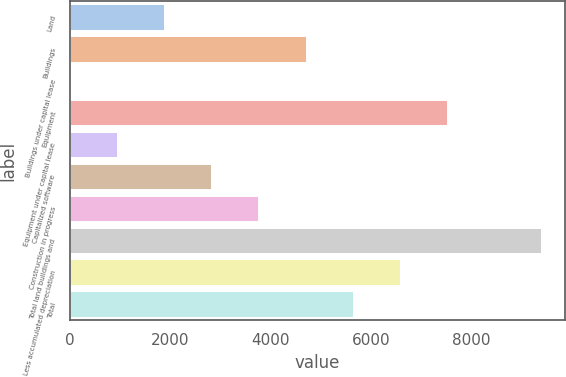<chart> <loc_0><loc_0><loc_500><loc_500><bar_chart><fcel>Land<fcel>Buildings<fcel>Buildings under capital lease<fcel>Equipment<fcel>Equipment under capital lease<fcel>Capitalized software<fcel>Construction in progress<fcel>Total land buildings and<fcel>Less accumulated depreciation<fcel>Total<nl><fcel>1878.86<fcel>4696.7<fcel>0.3<fcel>7514.54<fcel>939.58<fcel>2818.14<fcel>3757.42<fcel>9393.1<fcel>6575.26<fcel>5635.98<nl></chart> 